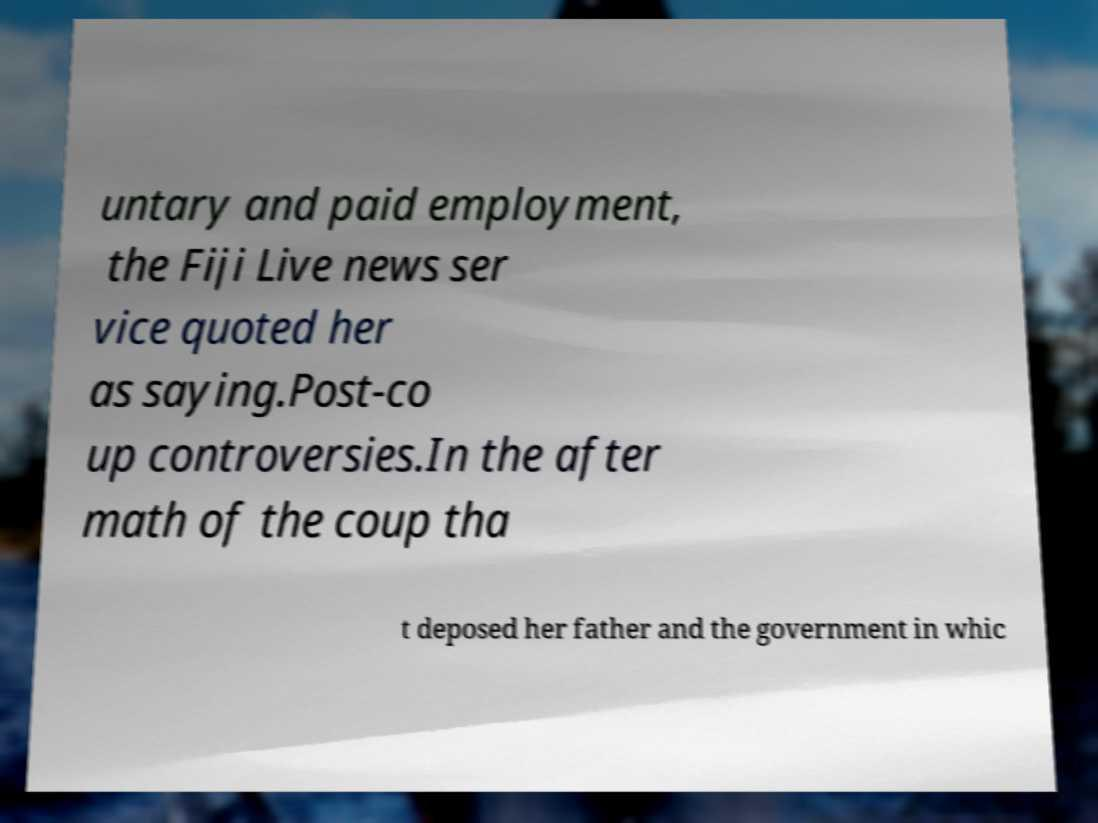I need the written content from this picture converted into text. Can you do that? untary and paid employment, the Fiji Live news ser vice quoted her as saying.Post-co up controversies.In the after math of the coup tha t deposed her father and the government in whic 